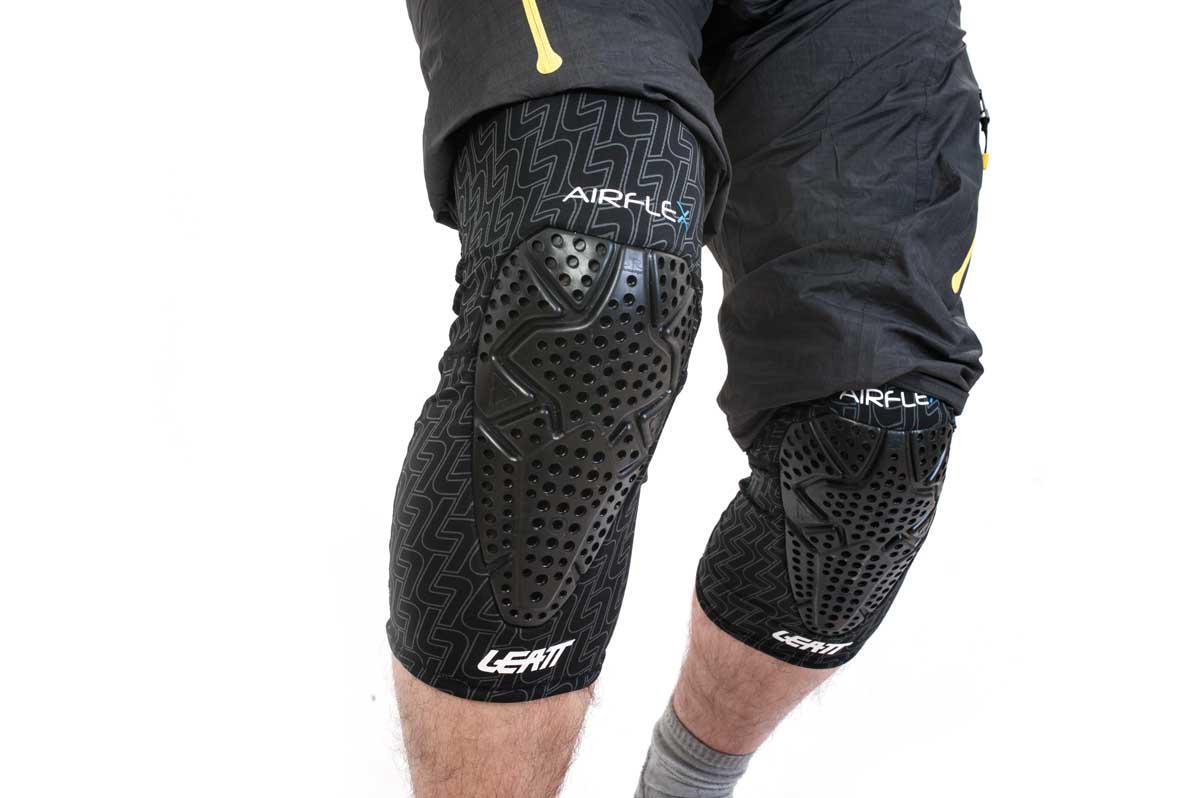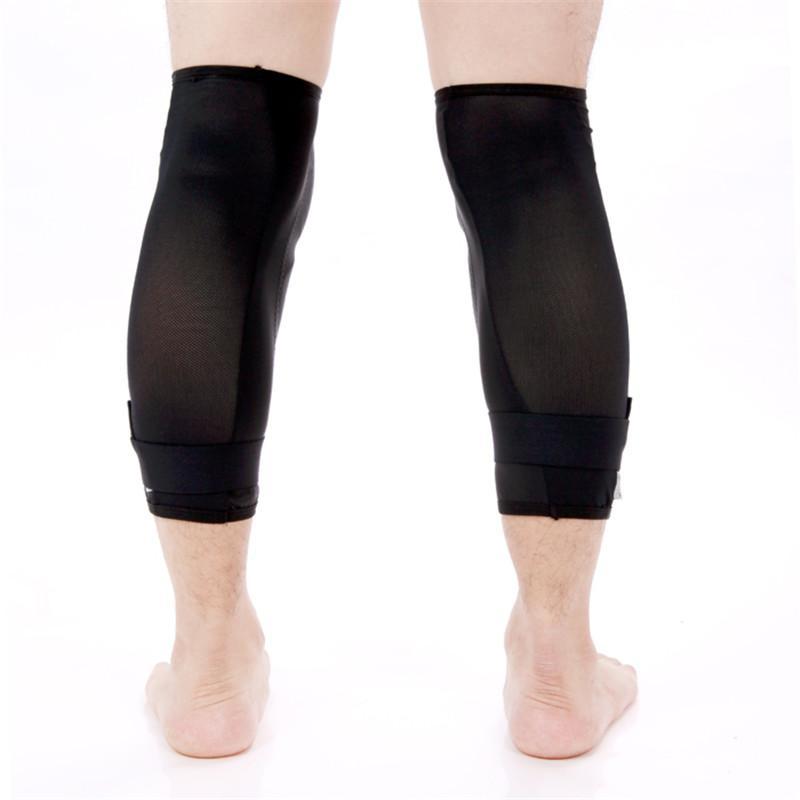The first image is the image on the left, the second image is the image on the right. For the images displayed, is the sentence "There are exactly four legs visible." factually correct? Answer yes or no. Yes. The first image is the image on the left, the second image is the image on the right. For the images shown, is this caption "There are two pairs of legs." true? Answer yes or no. Yes. 